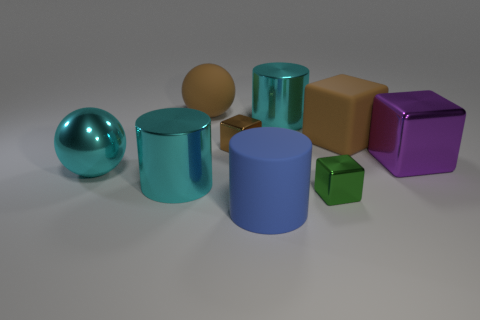Is there any other thing that has the same shape as the blue object? Yes, the green object on the right side has the same cylindrical shape as the large blue object in the center. 